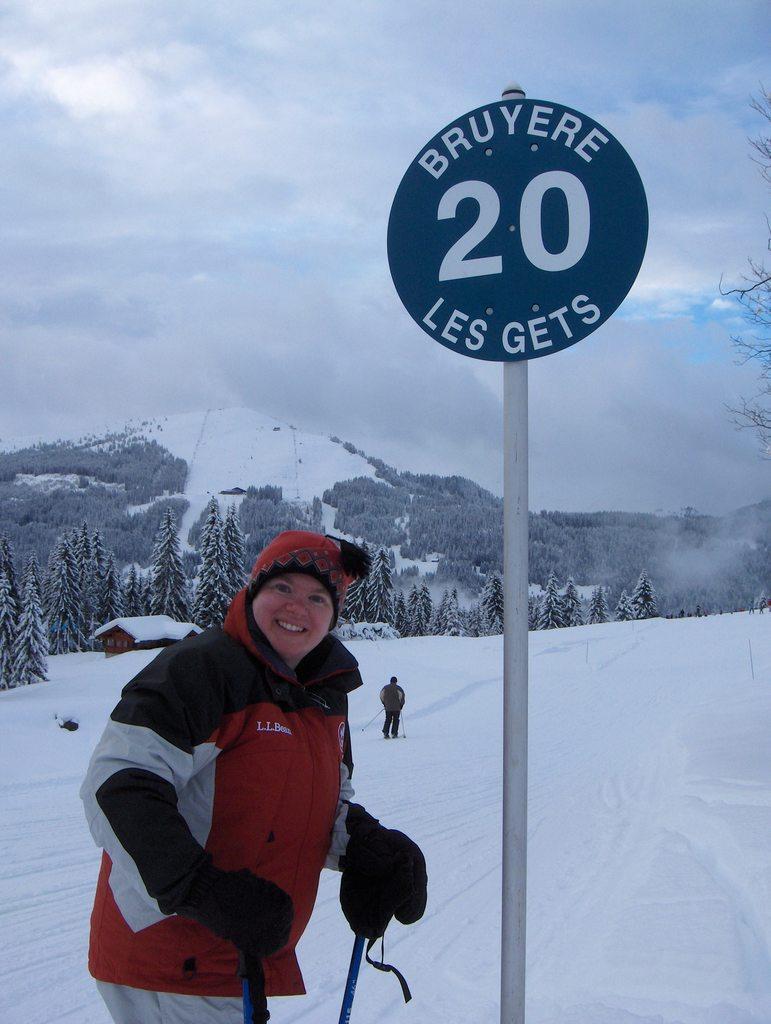How would you summarize this image in a sentence or two? In this image there is person, pole with some text on it in the foreground. There is snow at the bottom. There is a person, trees, building, mountains in the background. And there is a sky at the top. 